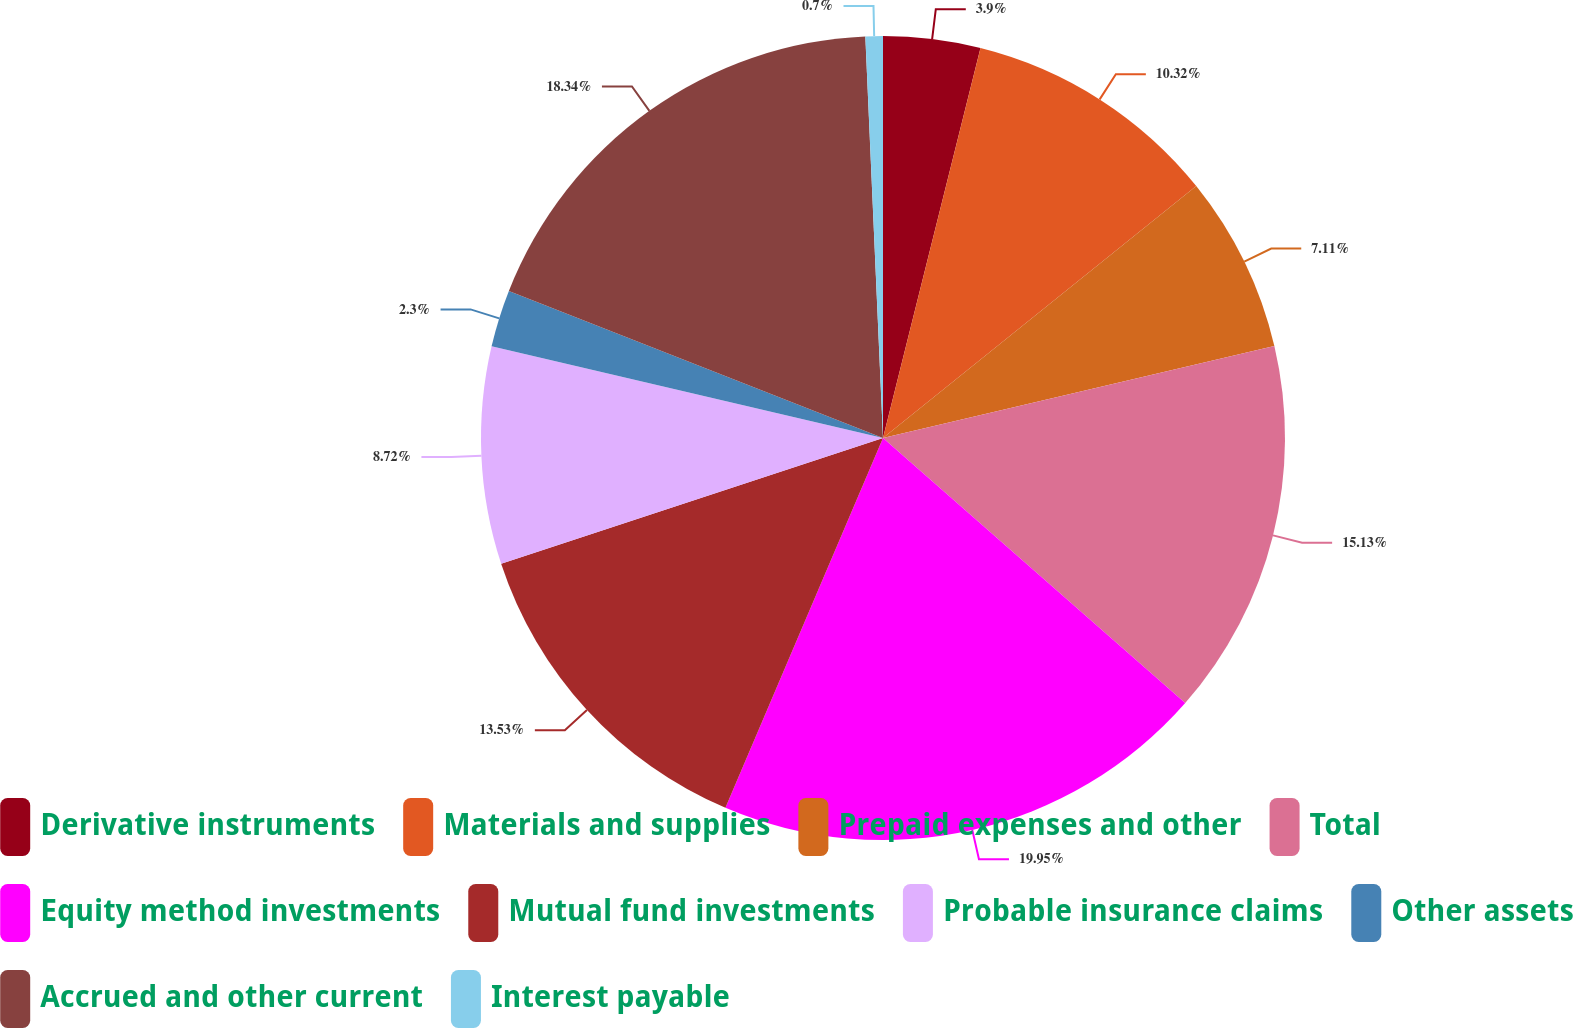Convert chart to OTSL. <chart><loc_0><loc_0><loc_500><loc_500><pie_chart><fcel>Derivative instruments<fcel>Materials and supplies<fcel>Prepaid expenses and other<fcel>Total<fcel>Equity method investments<fcel>Mutual fund investments<fcel>Probable insurance claims<fcel>Other assets<fcel>Accrued and other current<fcel>Interest payable<nl><fcel>3.9%<fcel>10.32%<fcel>7.11%<fcel>15.13%<fcel>19.95%<fcel>13.53%<fcel>8.72%<fcel>2.3%<fcel>18.34%<fcel>0.7%<nl></chart> 